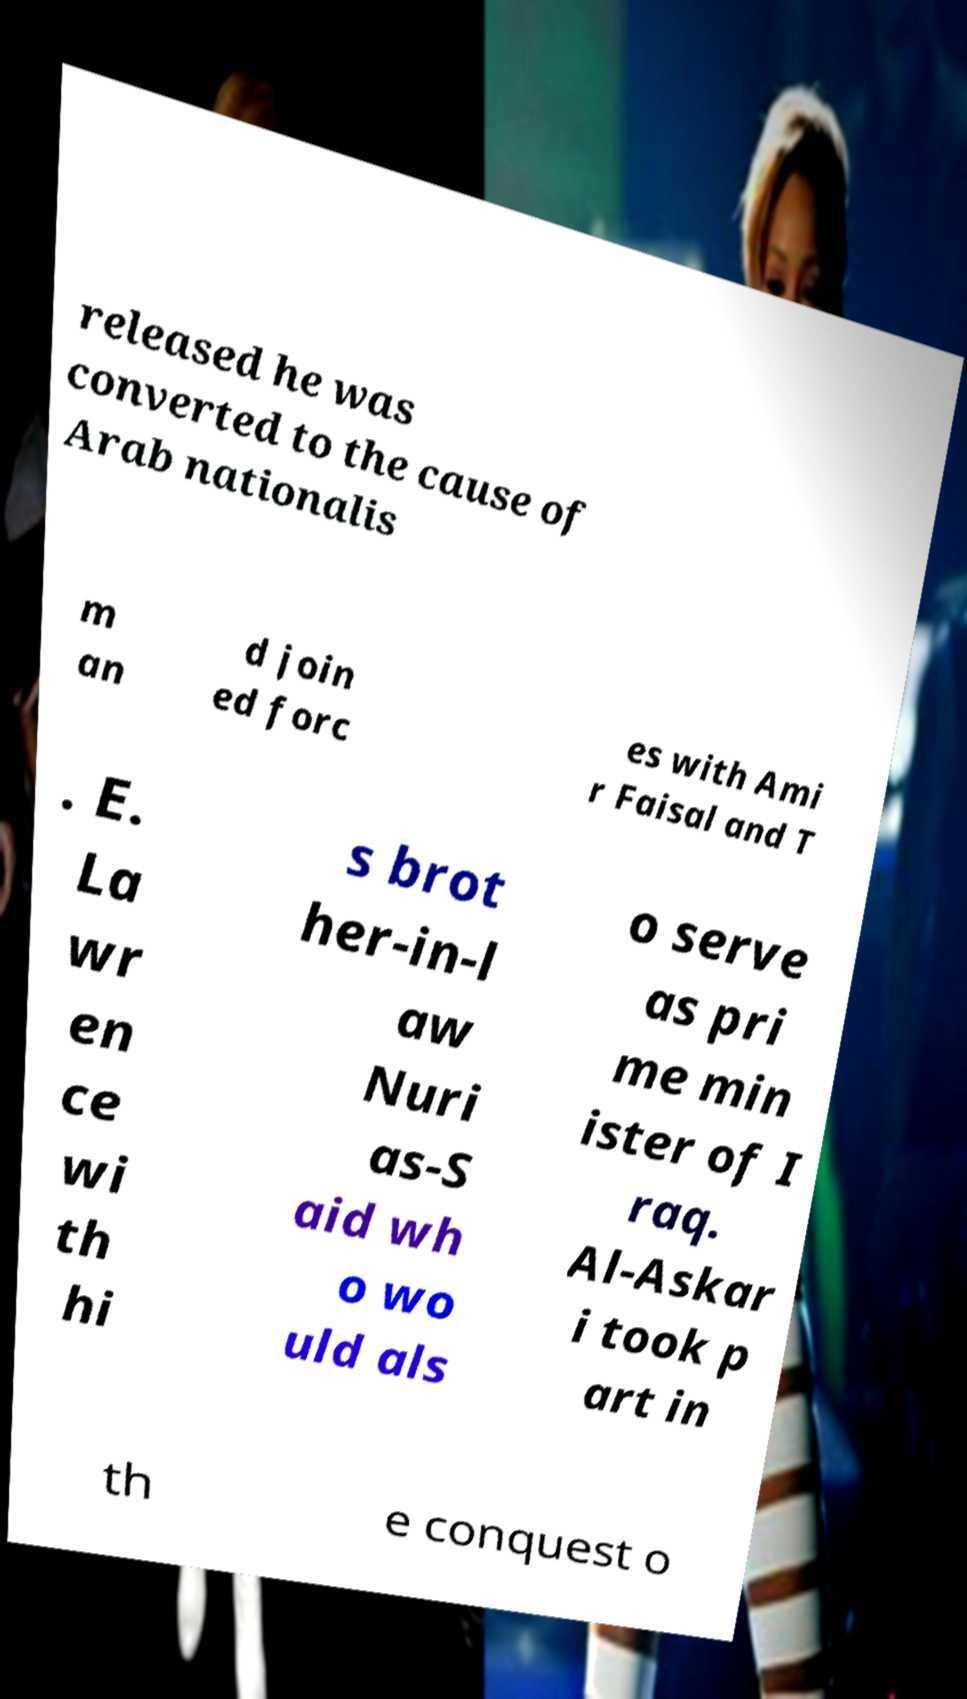Can you read and provide the text displayed in the image?This photo seems to have some interesting text. Can you extract and type it out for me? released he was converted to the cause of Arab nationalis m an d join ed forc es with Ami r Faisal and T . E. La wr en ce wi th hi s brot her-in-l aw Nuri as-S aid wh o wo uld als o serve as pri me min ister of I raq. Al-Askar i took p art in th e conquest o 